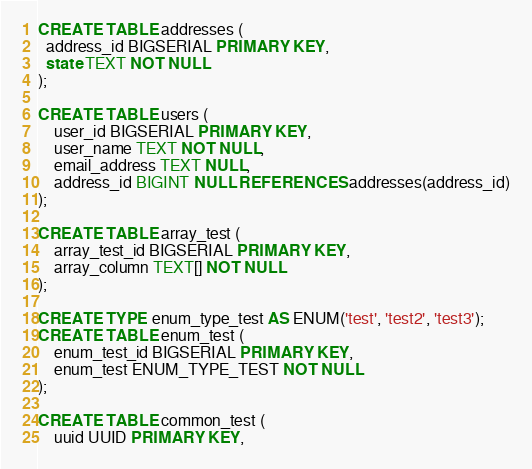Convert code to text. <code><loc_0><loc_0><loc_500><loc_500><_SQL_>CREATE TABLE addresses (
  address_id BIGSERIAL PRIMARY KEY,
  state TEXT NOT NULL
);

CREATE TABLE users (
	user_id BIGSERIAL PRIMARY KEY,
	user_name TEXT NOT NULL,
	email_address TEXT NULL,
	address_id BIGINT NULL REFERENCES addresses(address_id)
);

CREATE TABLE array_test (
	array_test_id BIGSERIAL PRIMARY KEY,
	array_column TEXT[] NOT NULL
);

CREATE TYPE enum_type_test AS ENUM('test', 'test2', 'test3');
CREATE TABLE enum_test (
	enum_test_id BIGSERIAL PRIMARY KEY,
	enum_test ENUM_TYPE_TEST NOT NULL
);

CREATE TABLE common_test (
	uuid UUID PRIMARY KEY,</code> 